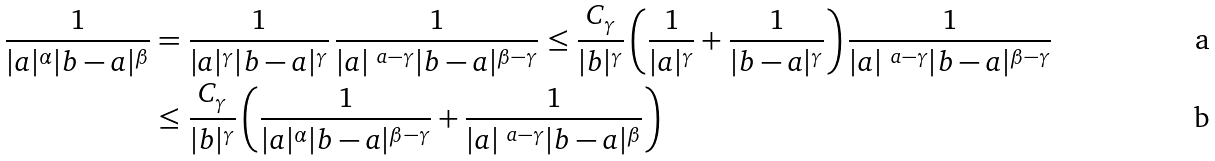Convert formula to latex. <formula><loc_0><loc_0><loc_500><loc_500>\frac { 1 } { | a | ^ { \alpha } | b - a | ^ { \beta } } & = \frac { 1 } { | a | ^ { \gamma } | b - a | ^ { \gamma } } \, \frac { 1 } { | a | ^ { \ a - \gamma } | b - a | ^ { \beta - \gamma } } \leq \frac { C _ { \gamma } } { | b | ^ { \gamma } } \left ( \frac { 1 } { | a | ^ { \gamma } } + \frac { 1 } { | b - a | ^ { \gamma } } \right ) \frac { 1 } { | a | ^ { \ a - \gamma } | b - a | ^ { \beta - \gamma } } \\ & \leq \frac { C _ { \gamma } } { | b | ^ { \gamma } } \left ( \frac { 1 } { | a | ^ { \alpha } | b - a | ^ { \beta - \gamma } } + \frac { 1 } { | a | ^ { \ a - \gamma } | b - a | ^ { \beta } } \right )</formula> 